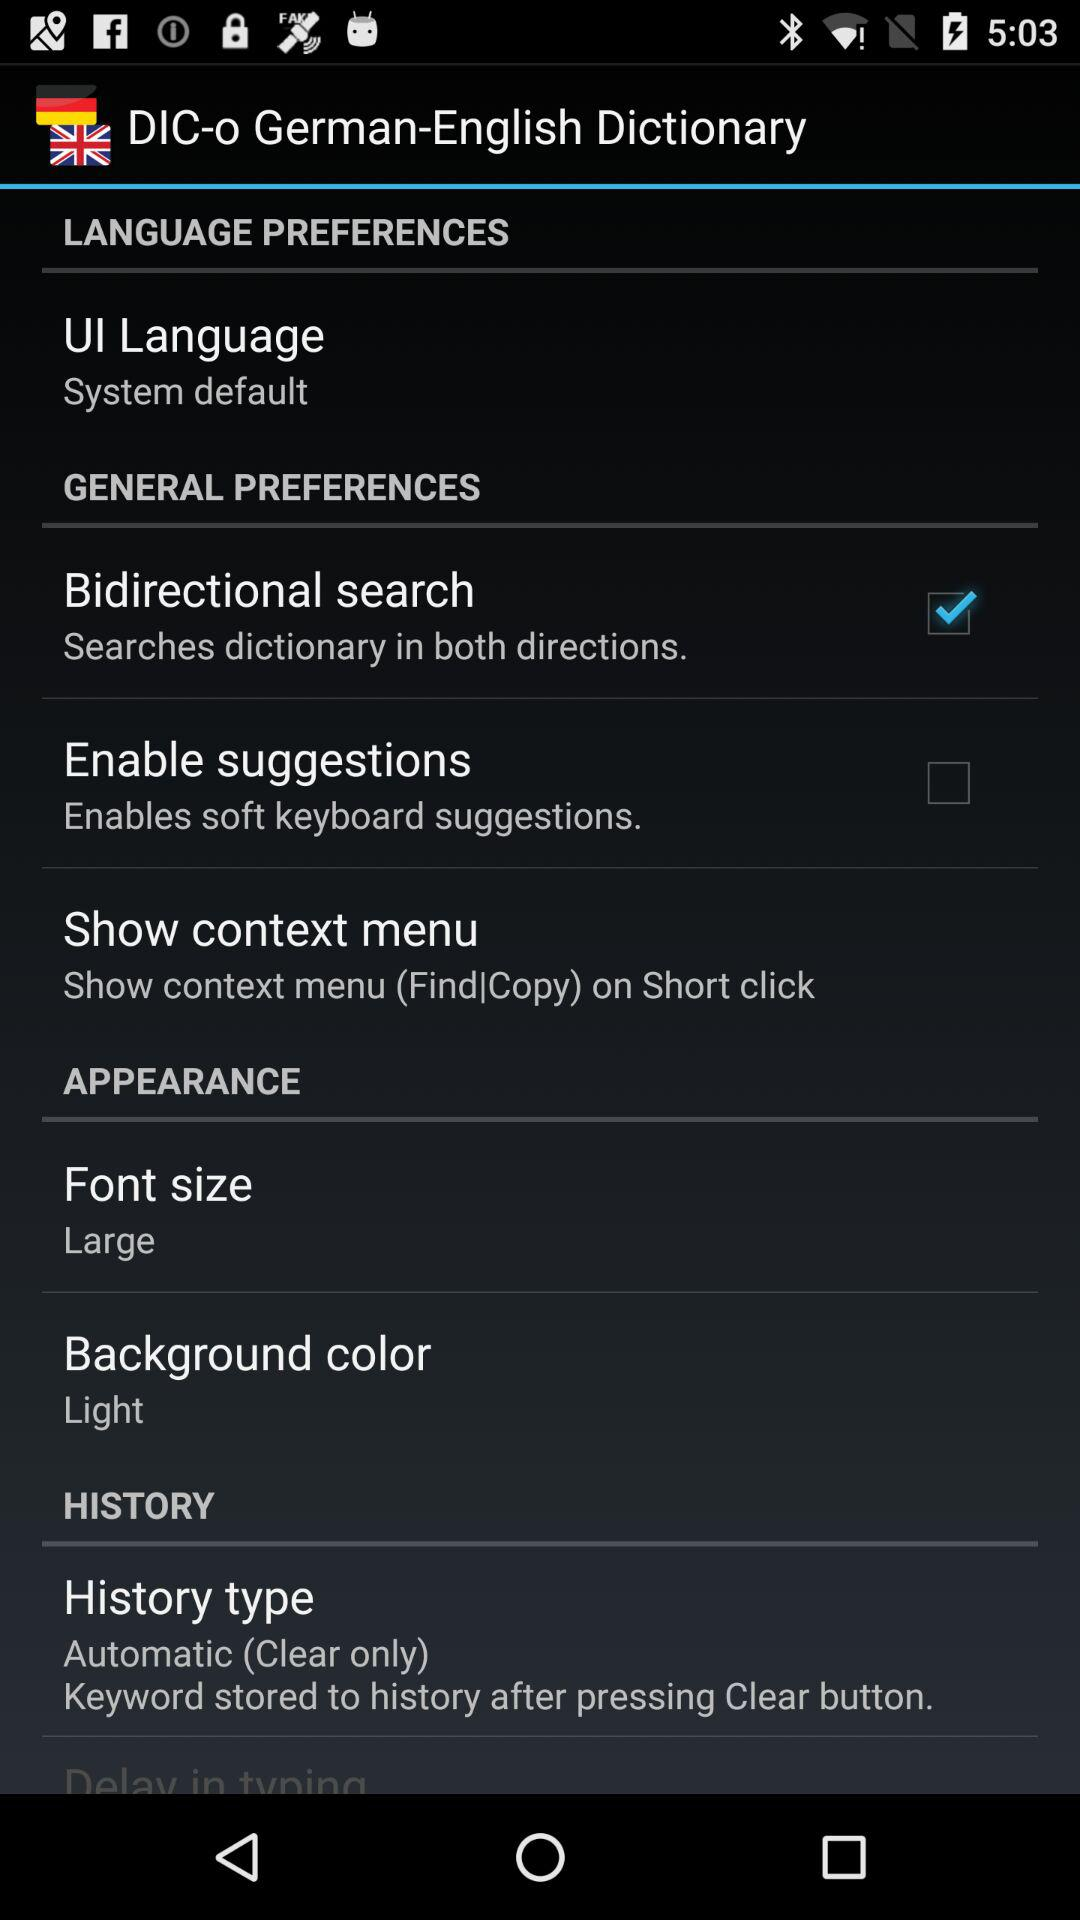How many items have a checkbox in the 'General Preferences' section?
Answer the question using a single word or phrase. 2 